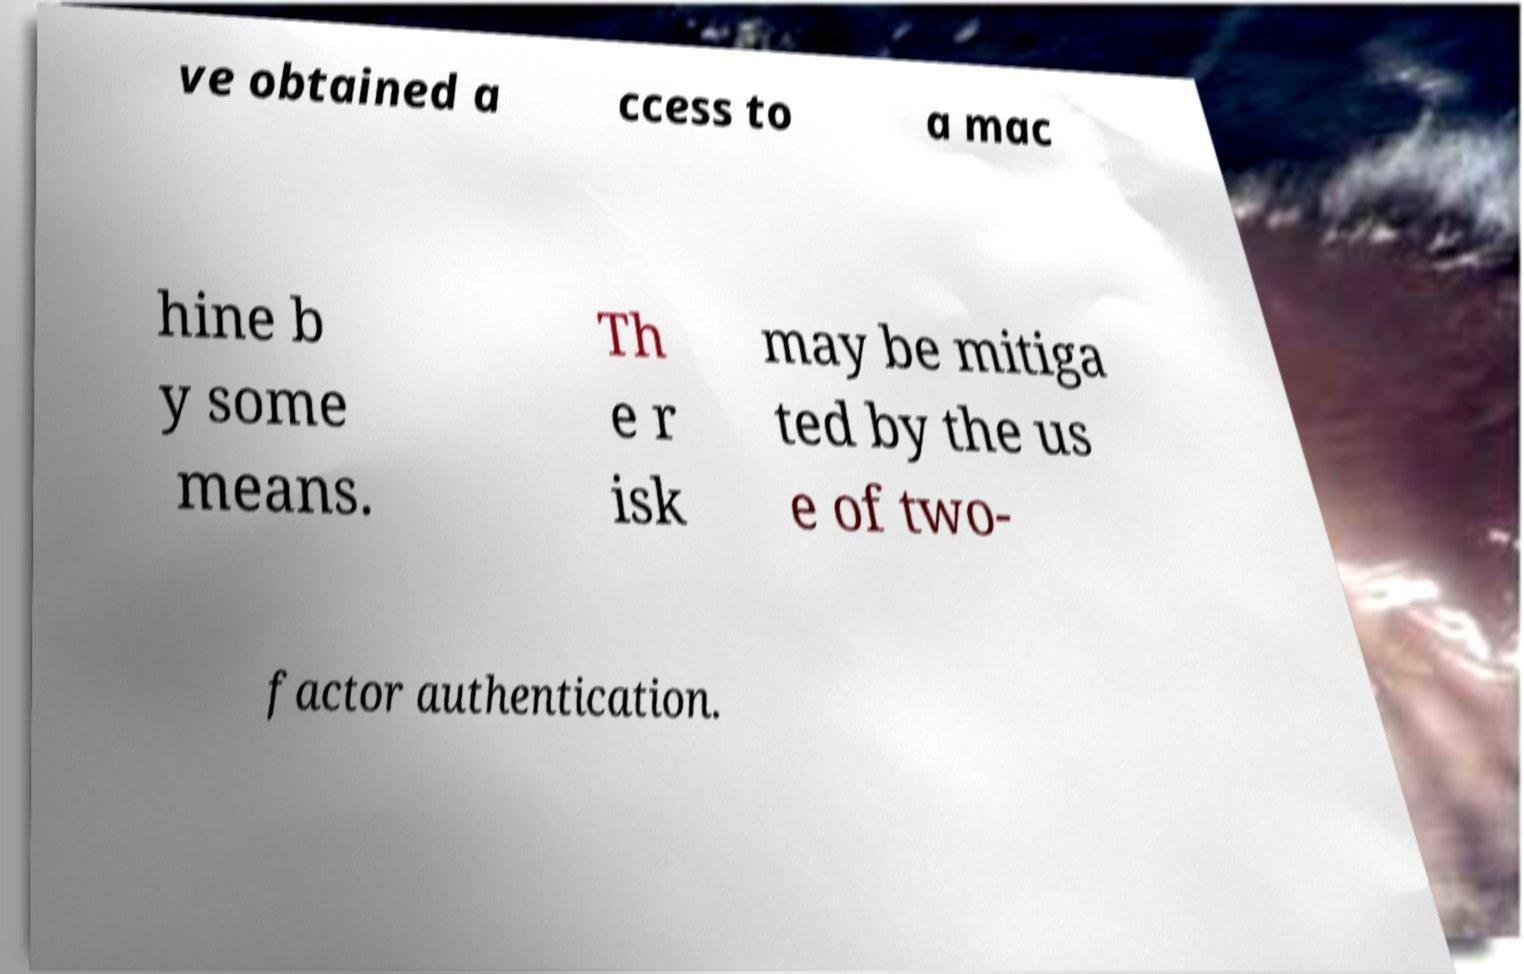Can you accurately transcribe the text from the provided image for me? ve obtained a ccess to a mac hine b y some means. Th e r isk may be mitiga ted by the us e of two- factor authentication. 